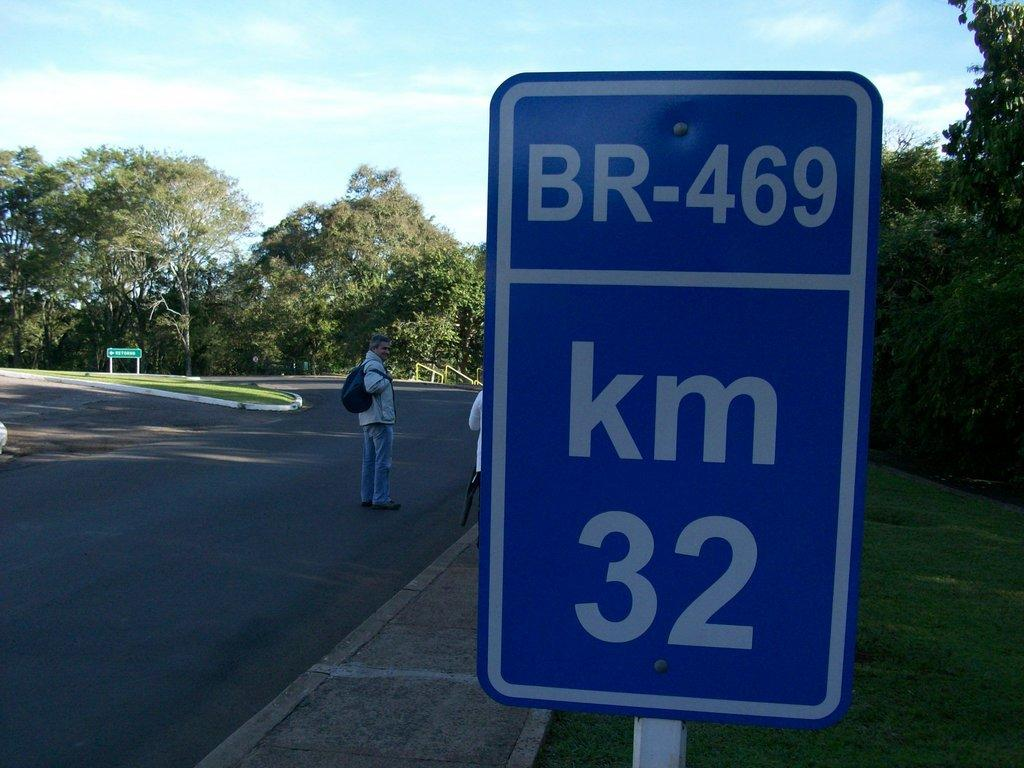<image>
Write a terse but informative summary of the picture. A blue sign on the side of the street says BR-469 and km 32. 